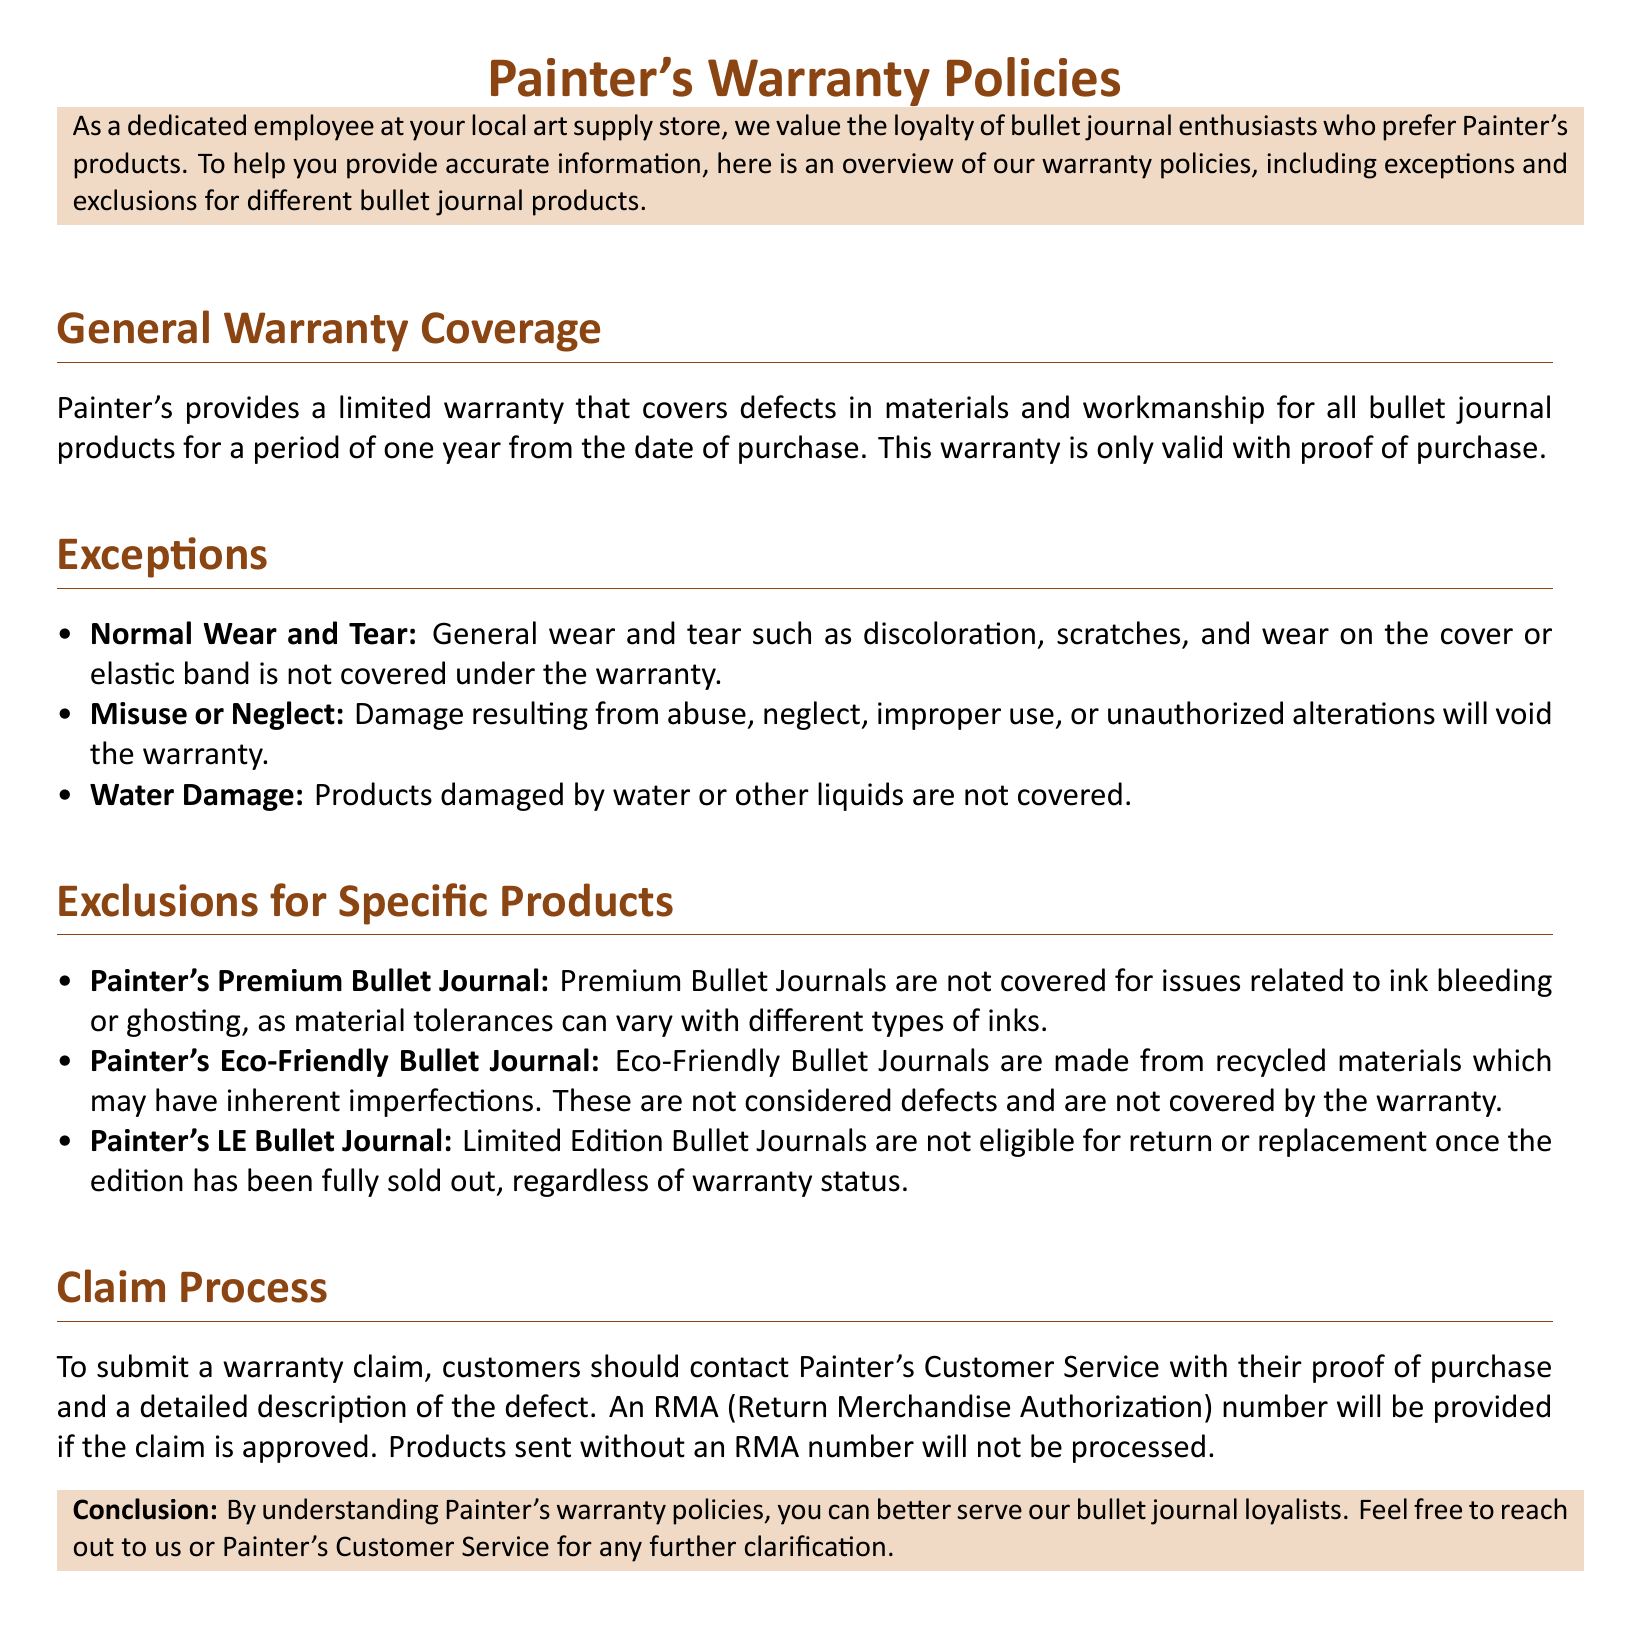What is the warranty period for Painter's bullet journal products? The warranty period covers defects in materials and workmanship for a period of one year from the date of purchase.
Answer: one year What types of damage are excluded from the warranty? The document lists several types of damage that are not covered, including wear and tear, misuse, and water damage.
Answer: wear and tear, misuse, water damage Which bullet journal is not covered for ink bleeding issues? The warranty specifies that issues related to ink bleeding or ghosting are not covered for a certain type of bullet journal product.
Answer: Painter's Premium Bullet Journal Are Eco-Friendly Bullet Journals covered for inherent imperfections? The document states that imperfections in Eco-Friendly Bullet Journals made from recycled materials are not considered defects.
Answer: not covered What must customers provide to submit a warranty claim? The document mentions that customers need to provide a specific piece of information along with a defect description to initiate a warranty claim.
Answer: proof of purchase How can customers contact Painter's for warranty claims? The document indicates that customers should reach out to Painter's Customer Service for warranty claim submissions.
Answer: Painter's Customer Service What happens to Limited Edition Bullet Journals after they sell out? The document specifies the status of Limited Edition Bullet Journals, particularly regarding returns or replacements once sold out.
Answer: not eligible for return or replacement What does RMA stand for in the claim process? The document includes an acronym that is essential for the warranty claim process, which customers need to be aware of.
Answer: Return Merchandise Authorization 